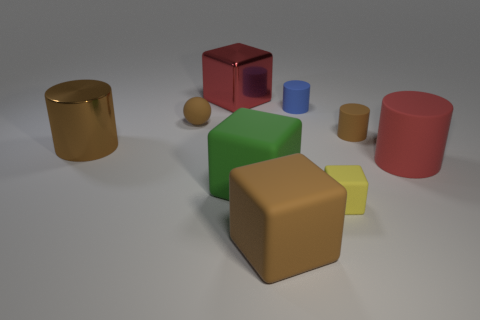There is a large matte thing that is the same color as the metal cylinder; what is its shape?
Your response must be concise. Cube. How many blue cylinders are the same size as the shiny block?
Ensure brevity in your answer.  0. The red object that is to the right of the red metal cube has what shape?
Give a very brief answer. Cylinder. Are there fewer green things than green cylinders?
Offer a very short reply. No. Are there any other things that have the same color as the sphere?
Make the answer very short. Yes. There is a cylinder that is to the left of the large green rubber cube; what size is it?
Offer a very short reply. Large. Are there more big red cylinders than small yellow cylinders?
Give a very brief answer. Yes. What is the yellow object made of?
Give a very brief answer. Rubber. How many other things are the same material as the big green cube?
Provide a short and direct response. 6. How many metal blocks are there?
Your answer should be compact. 1. 